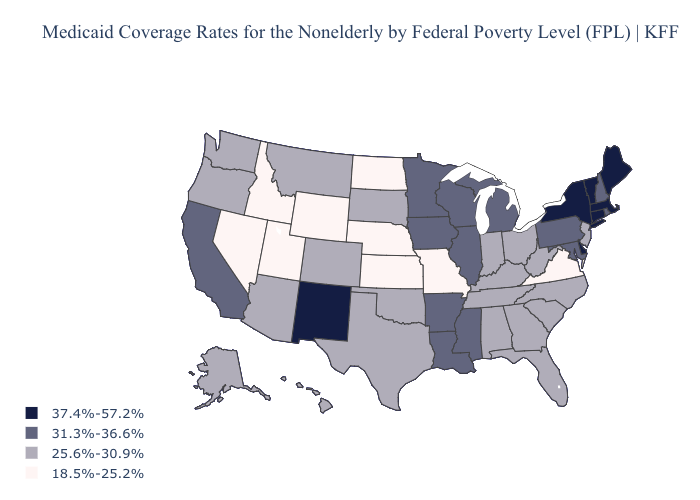Does New Mexico have a lower value than Montana?
Keep it brief. No. What is the value of North Dakota?
Write a very short answer. 18.5%-25.2%. Name the states that have a value in the range 31.3%-36.6%?
Short answer required. Arkansas, California, Illinois, Iowa, Louisiana, Maryland, Michigan, Minnesota, Mississippi, New Hampshire, Pennsylvania, Rhode Island, Wisconsin. Which states have the lowest value in the USA?
Short answer required. Idaho, Kansas, Missouri, Nebraska, Nevada, North Dakota, Utah, Virginia, Wyoming. What is the value of Maryland?
Be succinct. 31.3%-36.6%. Does Missouri have the lowest value in the USA?
Quick response, please. Yes. Does North Dakota have the lowest value in the USA?
Keep it brief. Yes. Among the states that border Oregon , which have the highest value?
Concise answer only. California. Among the states that border Nevada , does Oregon have the highest value?
Keep it brief. No. What is the value of North Carolina?
Concise answer only. 25.6%-30.9%. Does the map have missing data?
Concise answer only. No. How many symbols are there in the legend?
Quick response, please. 4. Which states have the lowest value in the USA?
Answer briefly. Idaho, Kansas, Missouri, Nebraska, Nevada, North Dakota, Utah, Virginia, Wyoming. What is the value of Louisiana?
Write a very short answer. 31.3%-36.6%. What is the value of Texas?
Concise answer only. 25.6%-30.9%. 